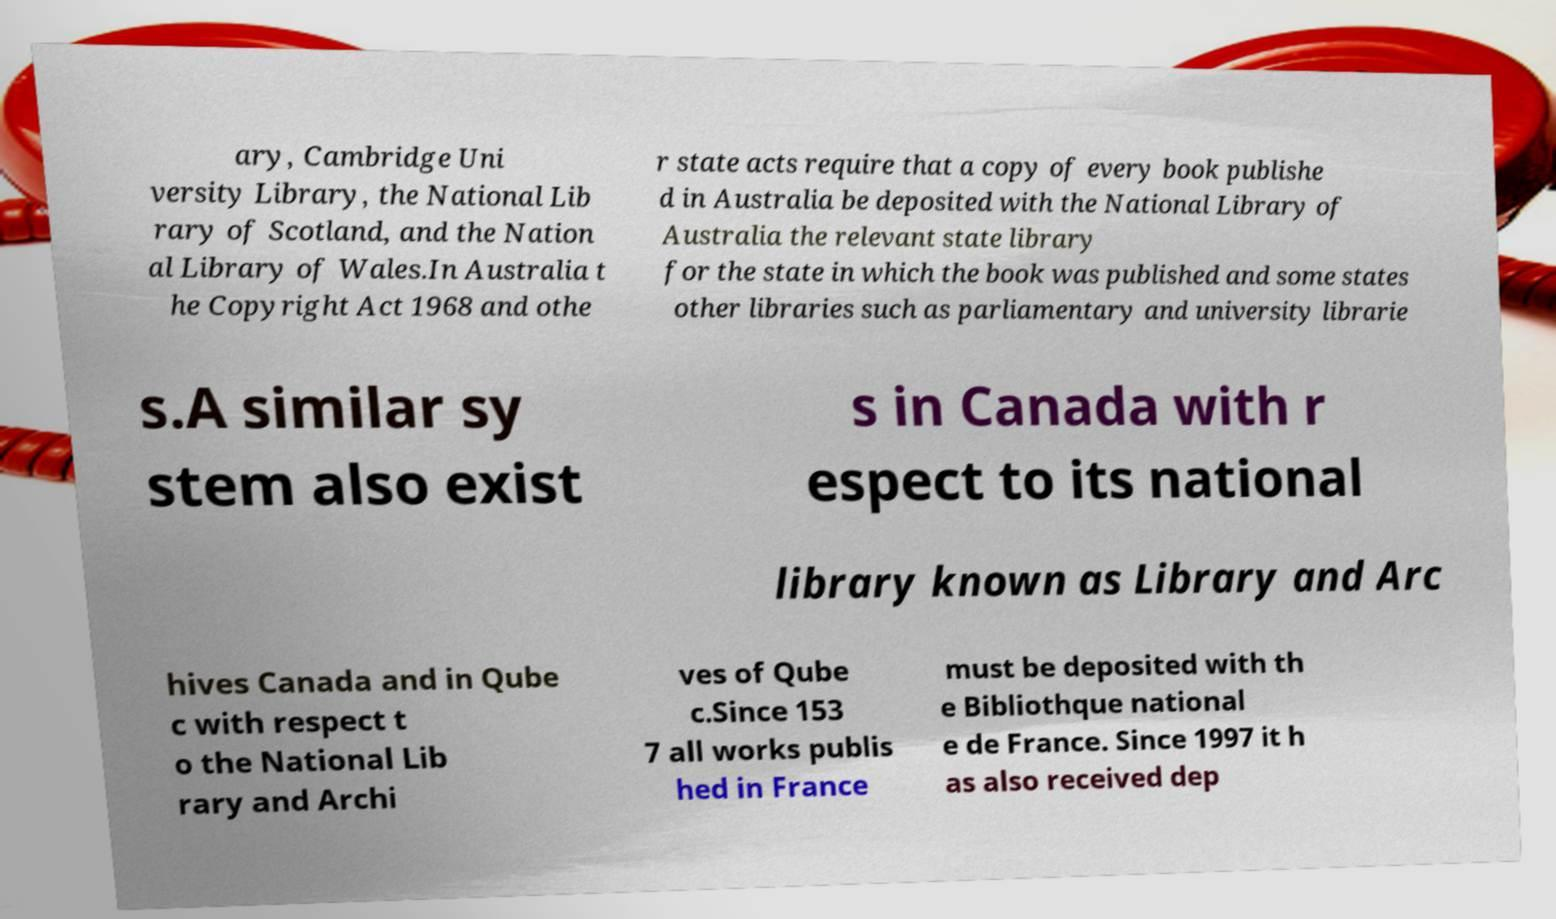Could you extract and type out the text from this image? ary, Cambridge Uni versity Library, the National Lib rary of Scotland, and the Nation al Library of Wales.In Australia t he Copyright Act 1968 and othe r state acts require that a copy of every book publishe d in Australia be deposited with the National Library of Australia the relevant state library for the state in which the book was published and some states other libraries such as parliamentary and university librarie s.A similar sy stem also exist s in Canada with r espect to its national library known as Library and Arc hives Canada and in Qube c with respect t o the National Lib rary and Archi ves of Qube c.Since 153 7 all works publis hed in France must be deposited with th e Bibliothque national e de France. Since 1997 it h as also received dep 